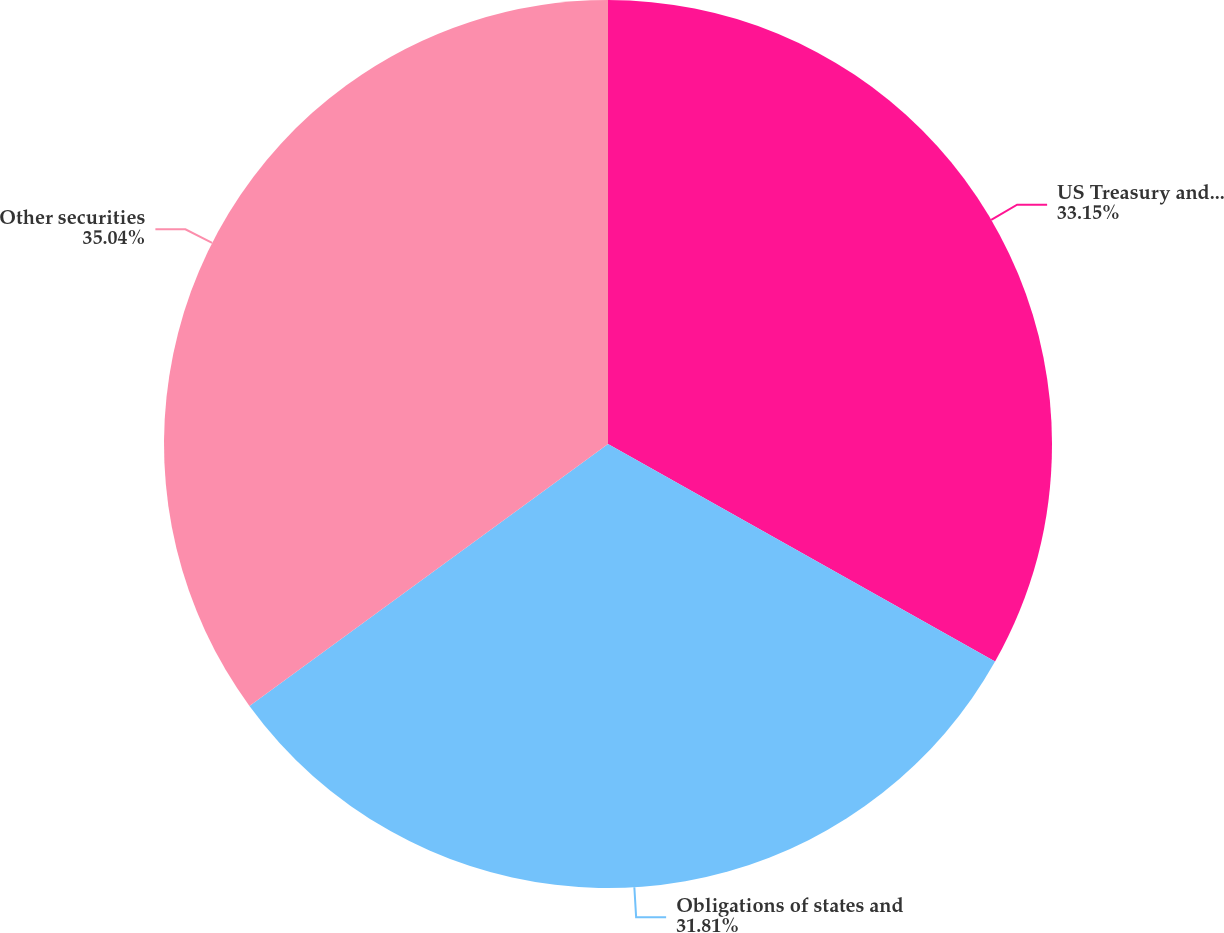Convert chart to OTSL. <chart><loc_0><loc_0><loc_500><loc_500><pie_chart><fcel>US Treasury and Federal agency<fcel>Obligations of states and<fcel>Other securities<nl><fcel>33.15%<fcel>31.81%<fcel>35.04%<nl></chart> 